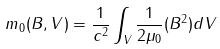Convert formula to latex. <formula><loc_0><loc_0><loc_500><loc_500>m _ { 0 } ( B , V ) = \frac { 1 } { c ^ { 2 } } \int _ { V } \frac { 1 } { 2 \mu _ { 0 } } ( B ^ { 2 } ) d V</formula> 